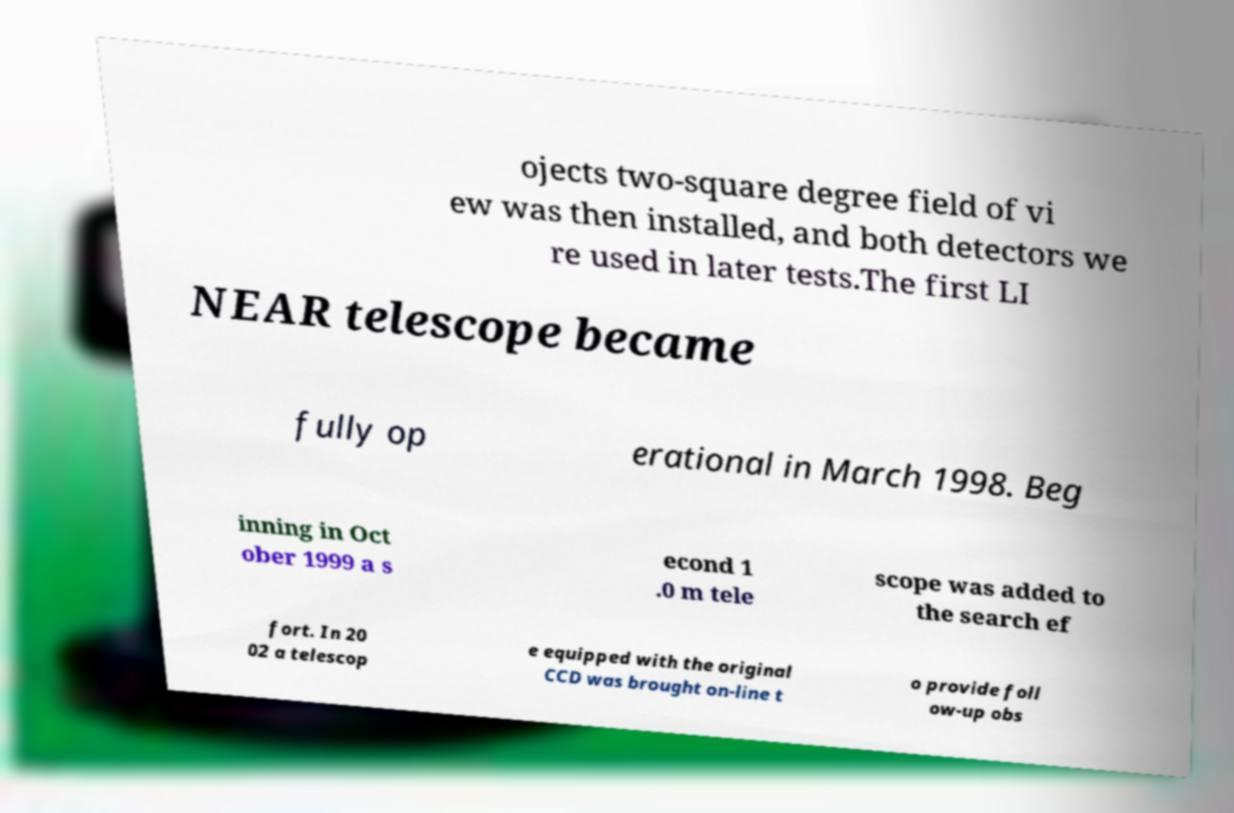Can you accurately transcribe the text from the provided image for me? ojects two-square degree field of vi ew was then installed, and both detectors we re used in later tests.The first LI NEAR telescope became fully op erational in March 1998. Beg inning in Oct ober 1999 a s econd 1 .0 m tele scope was added to the search ef fort. In 20 02 a telescop e equipped with the original CCD was brought on-line t o provide foll ow-up obs 